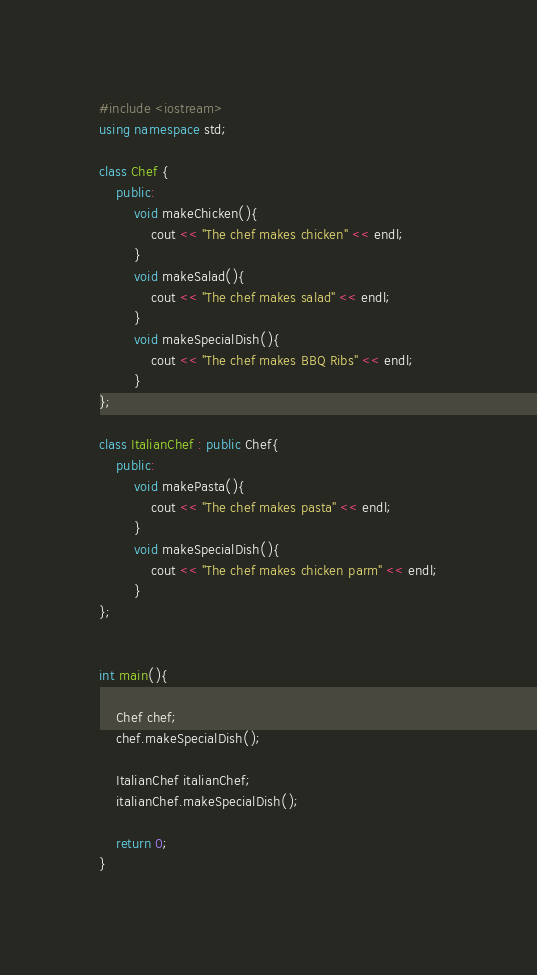Convert code to text. <code><loc_0><loc_0><loc_500><loc_500><_C++_>#include <iostream>
using namespace std;

class Chef {
    public:
        void makeChicken(){
            cout << "The chef makes chicken" << endl;
        }
        void makeSalad(){
            cout << "The chef makes salad" << endl;
        }
        void makeSpecialDish(){
            cout << "The chef makes BBQ Ribs" << endl;
        }
};

class ItalianChef : public Chef{
    public:
        void makePasta(){
            cout << "The chef makes pasta" << endl;
        }
        void makeSpecialDish(){
            cout << "The chef makes chicken parm" << endl;
        }
};


int main(){

    Chef chef;
    chef.makeSpecialDish();

    ItalianChef italianChef;
    italianChef.makeSpecialDish();

    return 0;
}</code> 